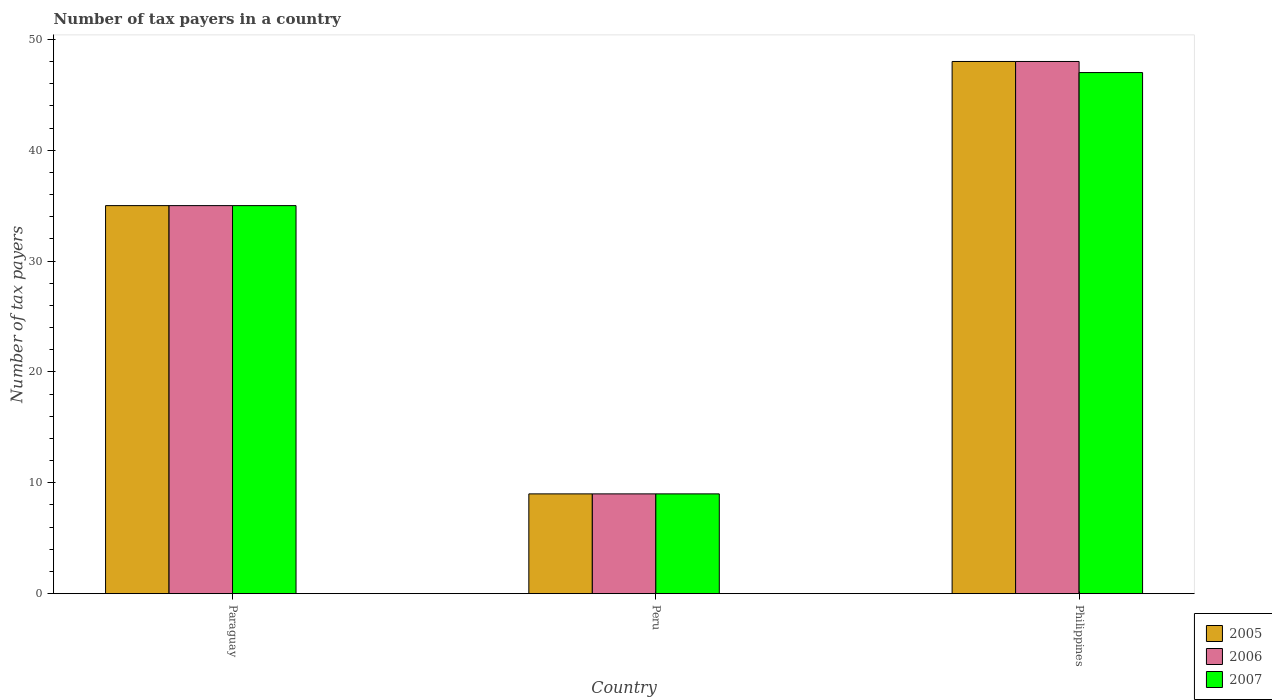How many groups of bars are there?
Offer a terse response. 3. How many bars are there on the 2nd tick from the right?
Your answer should be very brief. 3. In how many cases, is the number of bars for a given country not equal to the number of legend labels?
Offer a very short reply. 0. Across all countries, what is the maximum number of tax payers in in 2006?
Your response must be concise. 48. Across all countries, what is the minimum number of tax payers in in 2005?
Provide a succinct answer. 9. What is the total number of tax payers in in 2006 in the graph?
Give a very brief answer. 92. What is the difference between the number of tax payers in in 2006 in Paraguay and that in Peru?
Your answer should be compact. 26. What is the difference between the number of tax payers in in 2006 in Paraguay and the number of tax payers in in 2005 in Philippines?
Your answer should be very brief. -13. What is the average number of tax payers in in 2005 per country?
Your answer should be compact. 30.67. What is the difference between the number of tax payers in of/in 2006 and number of tax payers in of/in 2007 in Peru?
Offer a terse response. 0. In how many countries, is the number of tax payers in in 2005 greater than 48?
Provide a short and direct response. 0. What is the ratio of the number of tax payers in in 2005 in Paraguay to that in Peru?
Your response must be concise. 3.89. Is the difference between the number of tax payers in in 2006 in Peru and Philippines greater than the difference between the number of tax payers in in 2007 in Peru and Philippines?
Offer a terse response. No. What is the difference between the highest and the lowest number of tax payers in in 2005?
Ensure brevity in your answer.  39. In how many countries, is the number of tax payers in in 2005 greater than the average number of tax payers in in 2005 taken over all countries?
Offer a very short reply. 2. What does the 1st bar from the left in Peru represents?
Provide a short and direct response. 2005. Is it the case that in every country, the sum of the number of tax payers in in 2005 and number of tax payers in in 2006 is greater than the number of tax payers in in 2007?
Provide a short and direct response. Yes. Are all the bars in the graph horizontal?
Make the answer very short. No. How many countries are there in the graph?
Offer a very short reply. 3. What is the difference between two consecutive major ticks on the Y-axis?
Your answer should be compact. 10. Does the graph contain any zero values?
Ensure brevity in your answer.  No. Where does the legend appear in the graph?
Provide a short and direct response. Bottom right. How many legend labels are there?
Your response must be concise. 3. What is the title of the graph?
Your answer should be compact. Number of tax payers in a country. What is the label or title of the Y-axis?
Provide a short and direct response. Number of tax payers. What is the Number of tax payers of 2006 in Paraguay?
Your answer should be very brief. 35. What is the Number of tax payers of 2006 in Peru?
Provide a succinct answer. 9. What is the Number of tax payers in 2006 in Philippines?
Make the answer very short. 48. Across all countries, what is the maximum Number of tax payers of 2005?
Provide a short and direct response. 48. What is the total Number of tax payers in 2005 in the graph?
Your answer should be compact. 92. What is the total Number of tax payers of 2006 in the graph?
Your answer should be compact. 92. What is the total Number of tax payers of 2007 in the graph?
Provide a short and direct response. 91. What is the difference between the Number of tax payers of 2007 in Paraguay and that in Peru?
Your answer should be very brief. 26. What is the difference between the Number of tax payers of 2007 in Paraguay and that in Philippines?
Offer a terse response. -12. What is the difference between the Number of tax payers in 2005 in Peru and that in Philippines?
Your answer should be very brief. -39. What is the difference between the Number of tax payers in 2006 in Peru and that in Philippines?
Provide a short and direct response. -39. What is the difference between the Number of tax payers in 2007 in Peru and that in Philippines?
Ensure brevity in your answer.  -38. What is the difference between the Number of tax payers of 2005 in Paraguay and the Number of tax payers of 2006 in Peru?
Your answer should be compact. 26. What is the difference between the Number of tax payers of 2005 in Paraguay and the Number of tax payers of 2007 in Peru?
Ensure brevity in your answer.  26. What is the difference between the Number of tax payers of 2005 in Paraguay and the Number of tax payers of 2006 in Philippines?
Keep it short and to the point. -13. What is the difference between the Number of tax payers in 2005 in Paraguay and the Number of tax payers in 2007 in Philippines?
Give a very brief answer. -12. What is the difference between the Number of tax payers in 2005 in Peru and the Number of tax payers in 2006 in Philippines?
Offer a terse response. -39. What is the difference between the Number of tax payers in 2005 in Peru and the Number of tax payers in 2007 in Philippines?
Ensure brevity in your answer.  -38. What is the difference between the Number of tax payers in 2006 in Peru and the Number of tax payers in 2007 in Philippines?
Your response must be concise. -38. What is the average Number of tax payers in 2005 per country?
Your answer should be compact. 30.67. What is the average Number of tax payers in 2006 per country?
Your answer should be very brief. 30.67. What is the average Number of tax payers of 2007 per country?
Your answer should be compact. 30.33. What is the difference between the Number of tax payers in 2005 and Number of tax payers in 2007 in Paraguay?
Make the answer very short. 0. What is the difference between the Number of tax payers in 2006 and Number of tax payers in 2007 in Paraguay?
Your answer should be compact. 0. What is the difference between the Number of tax payers of 2006 and Number of tax payers of 2007 in Peru?
Ensure brevity in your answer.  0. What is the difference between the Number of tax payers of 2005 and Number of tax payers of 2006 in Philippines?
Your response must be concise. 0. What is the difference between the Number of tax payers in 2006 and Number of tax payers in 2007 in Philippines?
Your answer should be compact. 1. What is the ratio of the Number of tax payers of 2005 in Paraguay to that in Peru?
Give a very brief answer. 3.89. What is the ratio of the Number of tax payers of 2006 in Paraguay to that in Peru?
Give a very brief answer. 3.89. What is the ratio of the Number of tax payers in 2007 in Paraguay to that in Peru?
Offer a very short reply. 3.89. What is the ratio of the Number of tax payers of 2005 in Paraguay to that in Philippines?
Your answer should be compact. 0.73. What is the ratio of the Number of tax payers in 2006 in Paraguay to that in Philippines?
Offer a terse response. 0.73. What is the ratio of the Number of tax payers in 2007 in Paraguay to that in Philippines?
Ensure brevity in your answer.  0.74. What is the ratio of the Number of tax payers in 2005 in Peru to that in Philippines?
Your answer should be compact. 0.19. What is the ratio of the Number of tax payers of 2006 in Peru to that in Philippines?
Offer a terse response. 0.19. What is the ratio of the Number of tax payers in 2007 in Peru to that in Philippines?
Provide a succinct answer. 0.19. What is the difference between the highest and the lowest Number of tax payers in 2006?
Offer a very short reply. 39. What is the difference between the highest and the lowest Number of tax payers in 2007?
Provide a succinct answer. 38. 